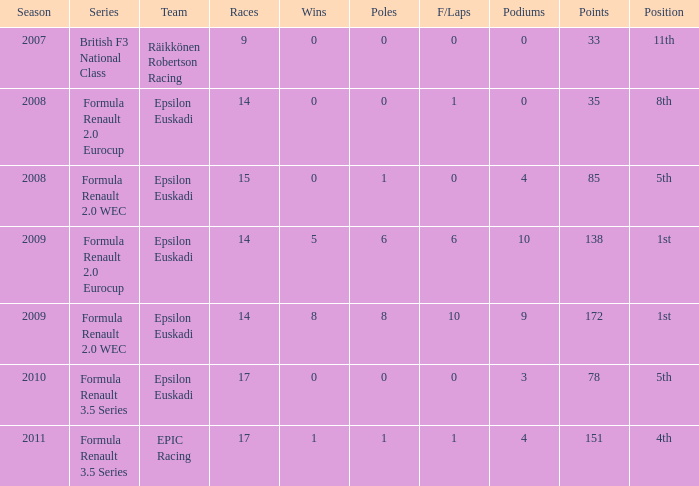What team was he on when he had 10 f/laps? Epsilon Euskadi. 